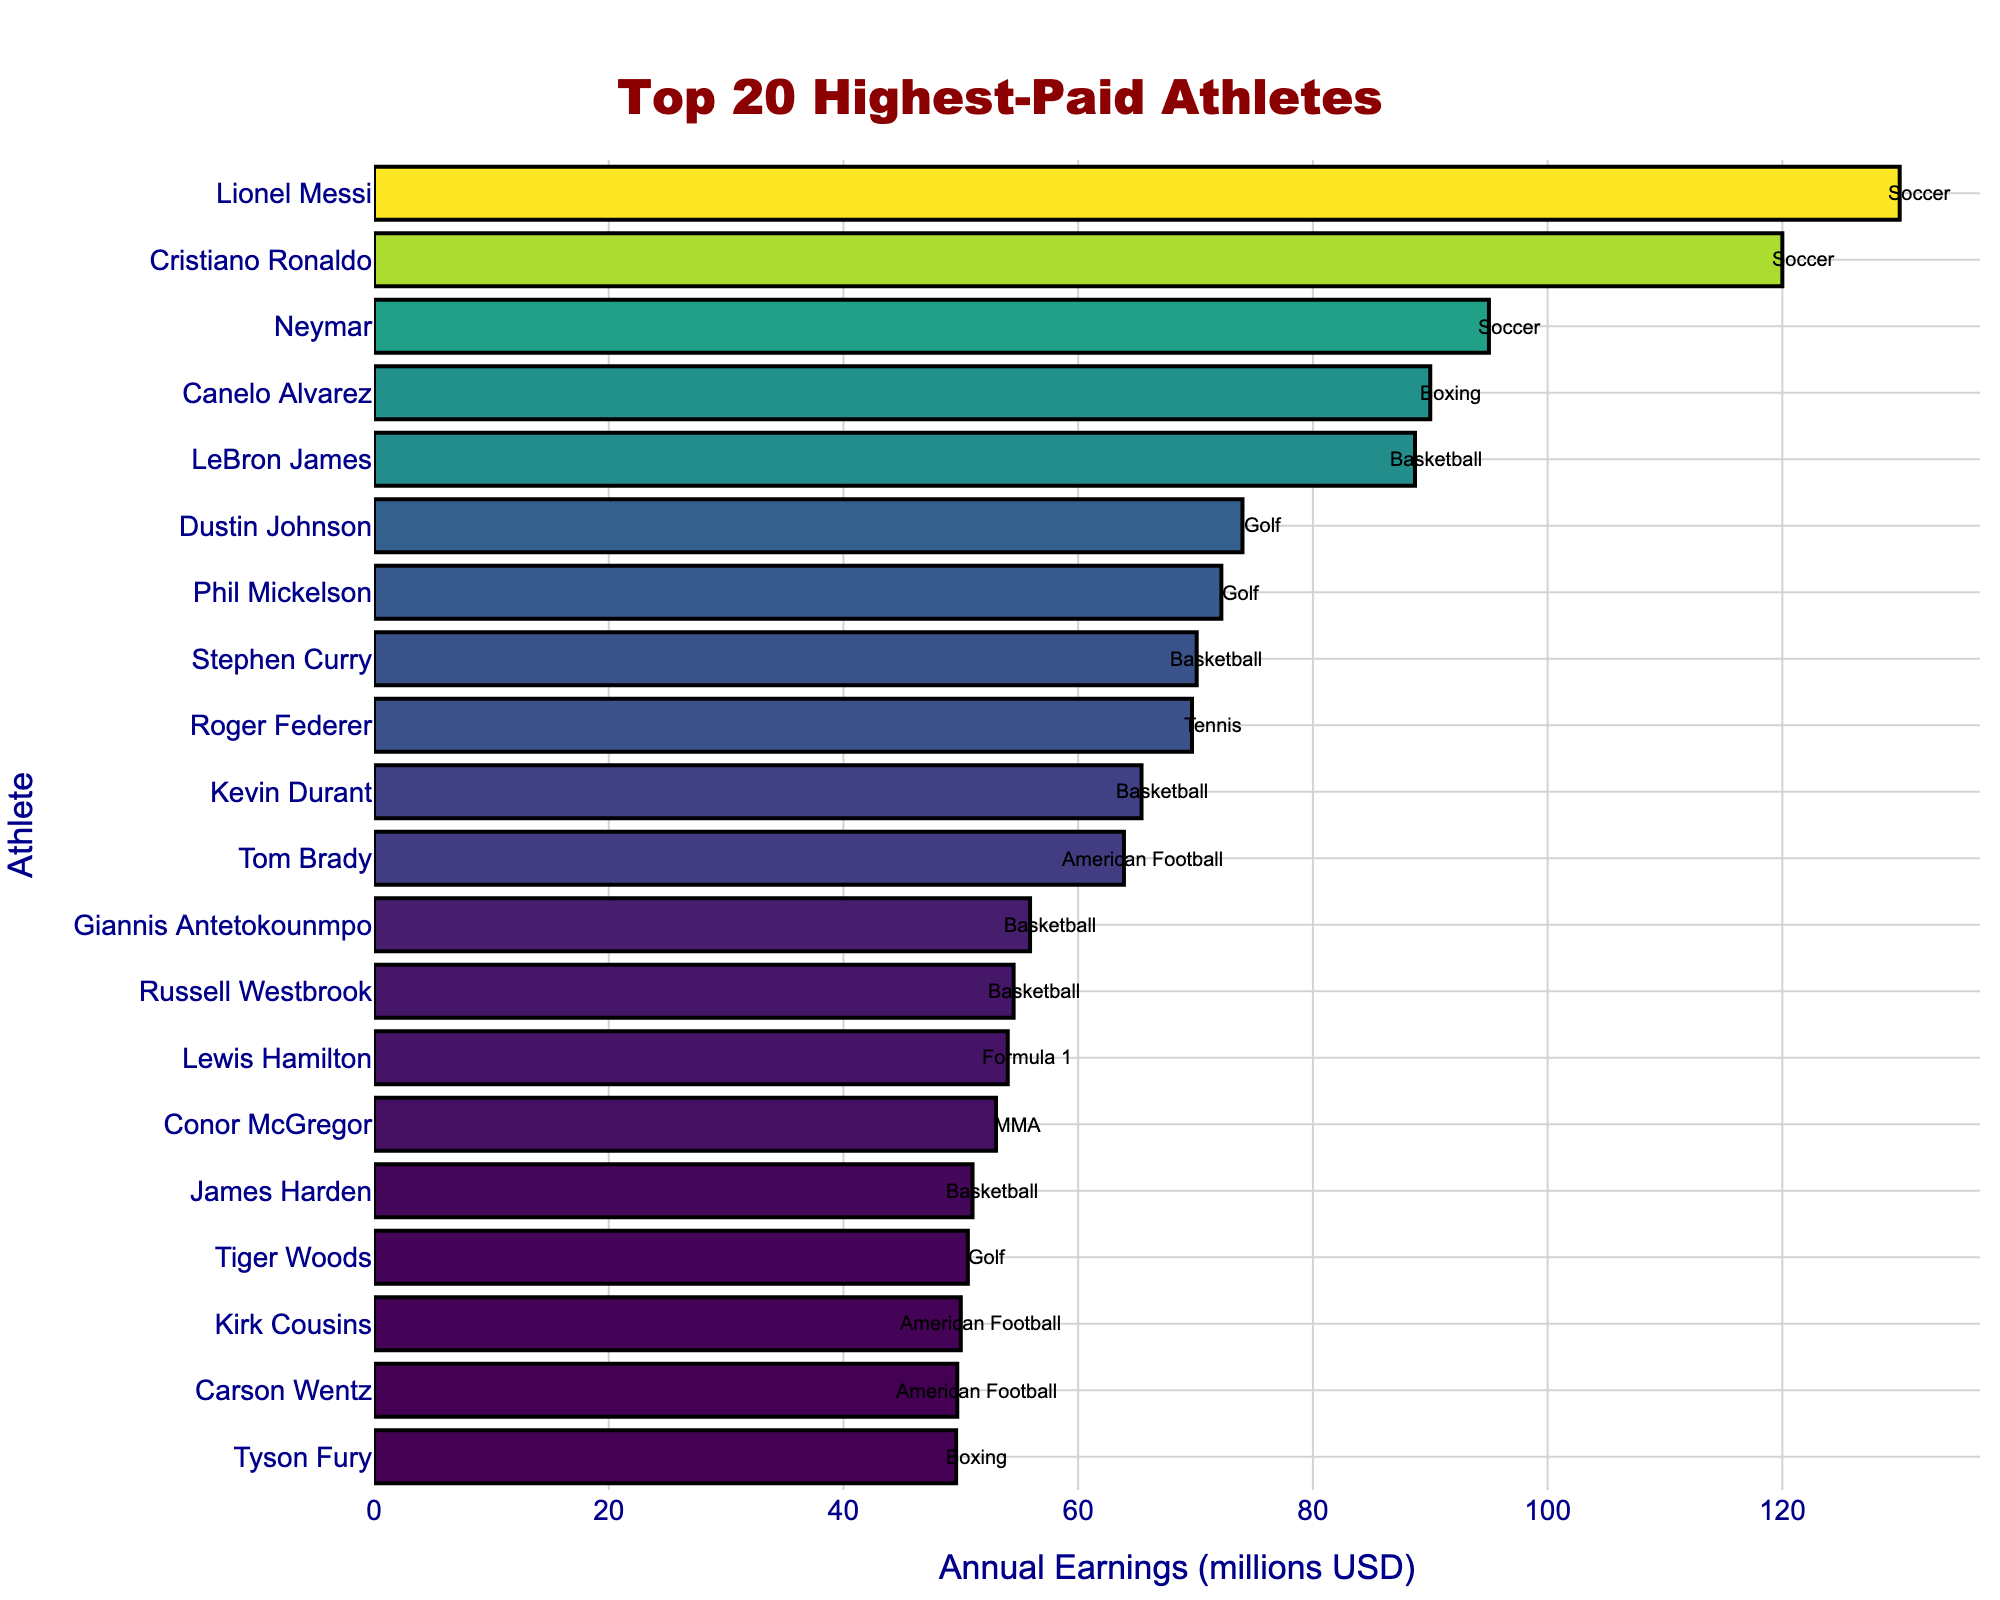Which athlete has the highest annual earnings? The highest bar represents the athlete with the highest annual earnings. The longest bar is associated with Lionel Messi.
Answer: Lionel Messi What is the total annual earnings of the top 2 highest-paid athletes? The top 2 highest-paid athletes are Lionel Messi and Cristiano Ronaldo, with earnings of $130 million and $120 million, respectively. Summing these gives 130 + 120 = 250.
Answer: 250 million USD Among the athletes, how many different sports are represented? By looking at the annotations next to each bar, we can see the sport each athlete is associated with. The list of unique sports includes Soccer, Boxing, Basketball, Golf, Tennis, American Football, Formula 1, MMA. Counting these gives a total of 8 different sports.
Answer: 8 Who is the highest-paid basketball player and what are their earnings? By observing the bars and their annotations related to Basketball, the highest bar among them is for LeBron James with an earning of $88.7 million.
Answer: LeBron James, 88.7 million USD What is the total annual earnings of all athletes listed in the plot? Sum the annual earnings of all 20 athletes provided in the data. This step requires summing all individual earnings: 130 + 120 + 95 + 90 + 88.7 + 74 + 72.2 + 70.1 + 69.7 + 65.4 + 63.9 + 55.9 + 54.5 + 54 + 53 + 51 + 50.6 + 50 + 49.7 + 49.6 = 1362.3.
Answer: 1362.3 million USD Which athlete's earnings are closest to the median of the top 20? First, sort the earnings to find the median. The list of earnings in ascending order is: 49.6, 49.7, 50, 50.6, 51, 53, 54, 54.5, 55.9, 63.9, 65.4, 69.7, 70.1, 72.2, 74, 88.7, 90, 95, 120, 130. The median is the average of the 10th and 11th values: (63.9 + 65.4) / 2 = 64.65. Kevin Durant, with $65.4 million earnings, is the closest to this value.
Answer: Kevin Durant Compare the earnings of the top soccer player with the top basketball player. Who earns more and by how much? The top soccer player is Lionel Messi with $130 million, and the top basketball player is LeBron James with $88.7 million. The difference in their earnings is 130 - 88.7 = 41.3.
Answer: Lionel Messi, 41.3 million USD What is the combined annual earnings of all basketball players listed in the plot? To find the combined earnings of basketball players, add the earnings of LeBron James, Stephen Curry, Kevin Durant, Giannis Antetokounmpo, Russell Westbrook, and James Harden. This gives: 88.7 + 70.1 + 65.4 + 55.9 + 54.5 + 51 = 385.6 million USD.
Answer: 385.6 million USD 